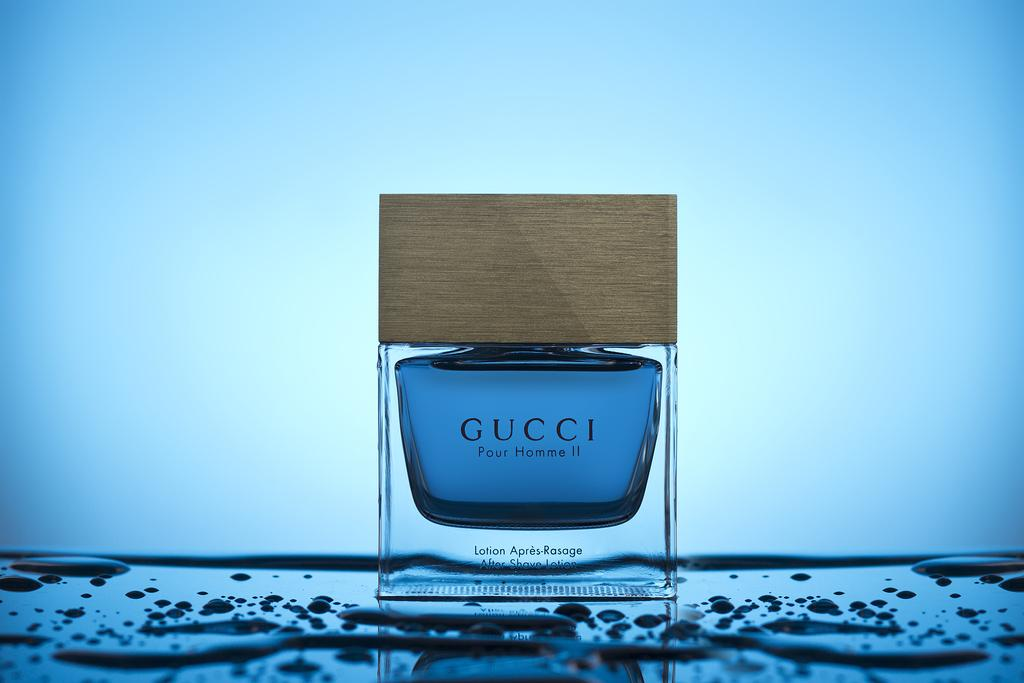<image>
Write a terse but informative summary of the picture. A bottle of Gucci Perfume sits on a table with drops of water. 